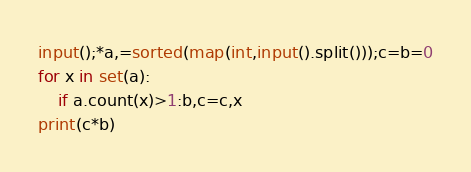Convert code to text. <code><loc_0><loc_0><loc_500><loc_500><_Python_>input();*a,=sorted(map(int,input().split()));c=b=0
for x in set(a):
    if a.count(x)>1:b,c=c,x
print(c*b)</code> 